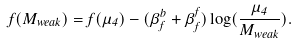Convert formula to latex. <formula><loc_0><loc_0><loc_500><loc_500>f ( M _ { w e a k } ) = f ( \mu _ { 4 } ) - ( \beta _ { f } ^ { b } + \beta _ { f } ^ { f } ) \log ( { \frac { \mu _ { 4 } } { M _ { w e a k } } } ) .</formula> 